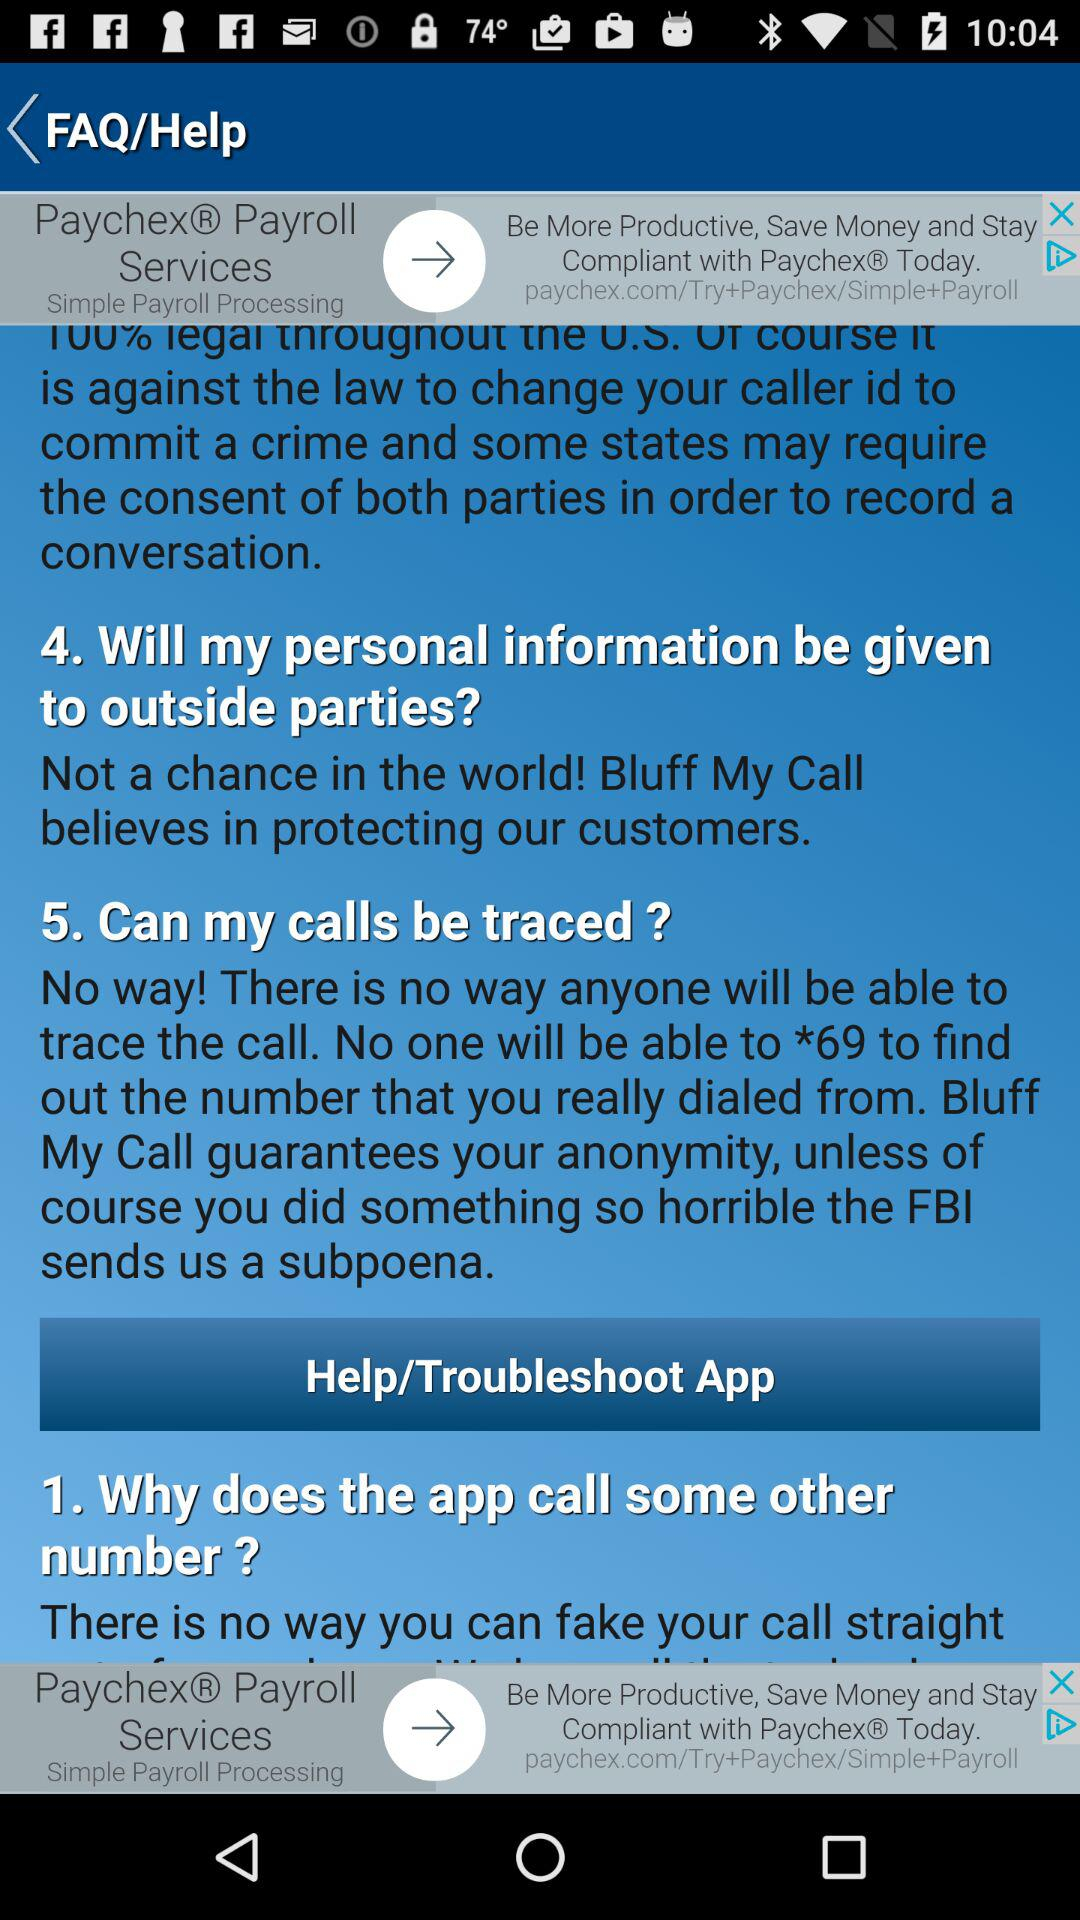How many questions does this FAQ have?
Answer the question using a single word or phrase. 5 